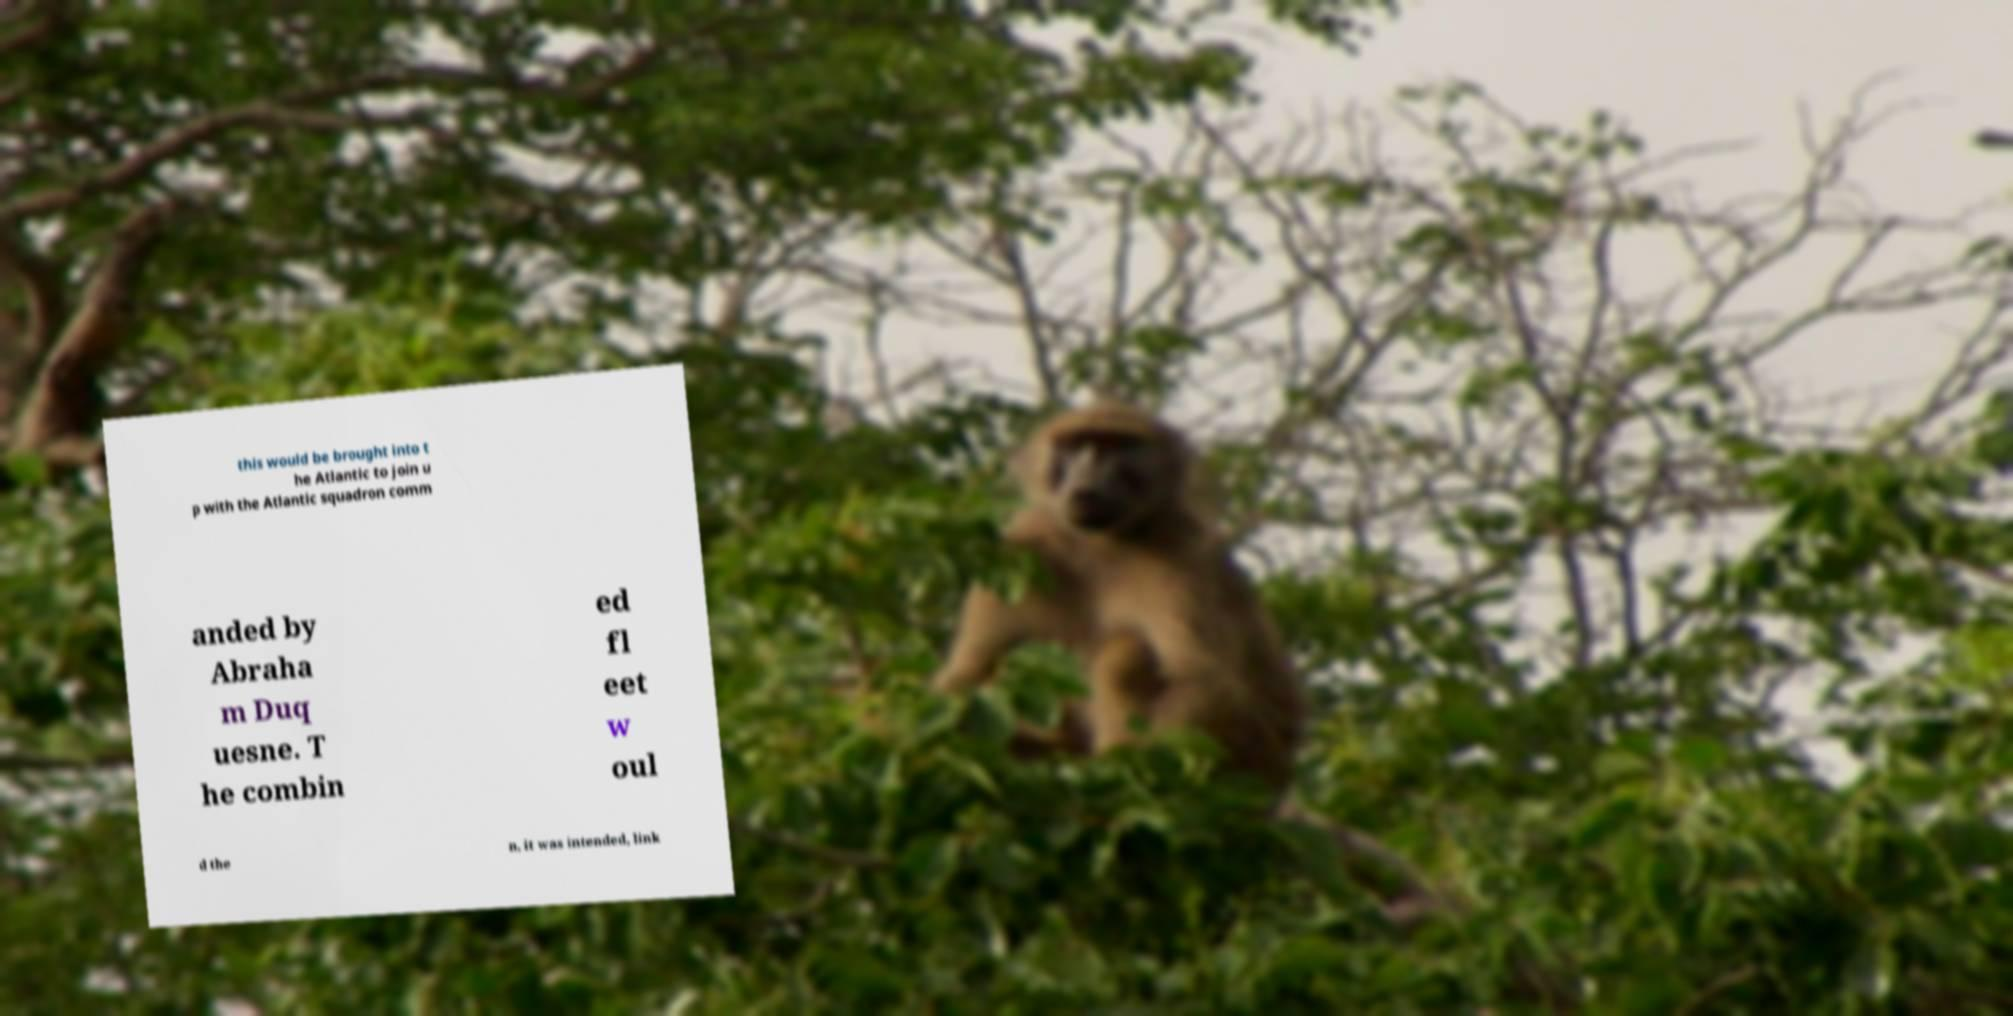Please read and relay the text visible in this image. What does it say? this would be brought into t he Atlantic to join u p with the Atlantic squadron comm anded by Abraha m Duq uesne. T he combin ed fl eet w oul d the n, it was intended, link 